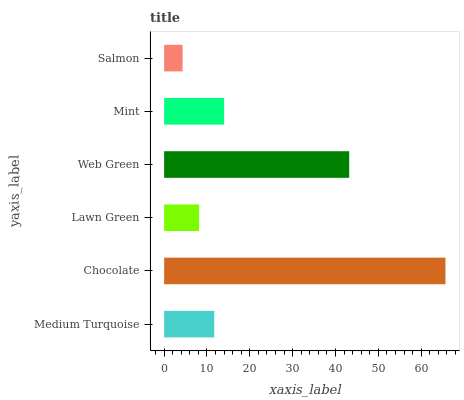Is Salmon the minimum?
Answer yes or no. Yes. Is Chocolate the maximum?
Answer yes or no. Yes. Is Lawn Green the minimum?
Answer yes or no. No. Is Lawn Green the maximum?
Answer yes or no. No. Is Chocolate greater than Lawn Green?
Answer yes or no. Yes. Is Lawn Green less than Chocolate?
Answer yes or no. Yes. Is Lawn Green greater than Chocolate?
Answer yes or no. No. Is Chocolate less than Lawn Green?
Answer yes or no. No. Is Mint the high median?
Answer yes or no. Yes. Is Medium Turquoise the low median?
Answer yes or no. Yes. Is Chocolate the high median?
Answer yes or no. No. Is Mint the low median?
Answer yes or no. No. 